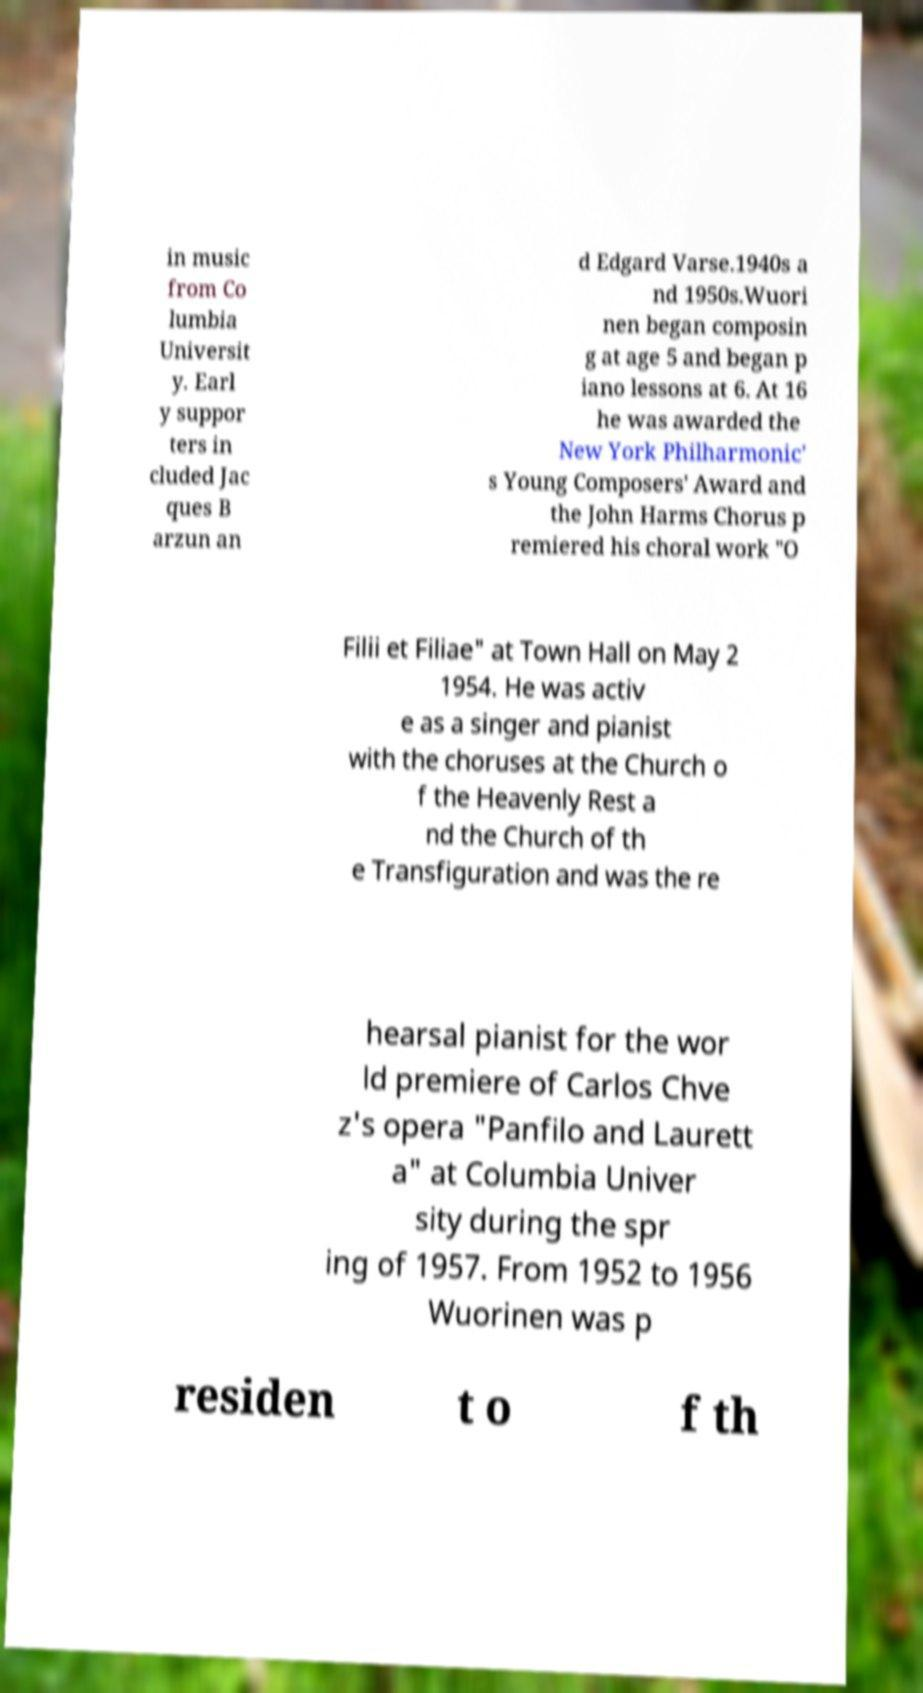There's text embedded in this image that I need extracted. Can you transcribe it verbatim? in music from Co lumbia Universit y. Earl y suppor ters in cluded Jac ques B arzun an d Edgard Varse.1940s a nd 1950s.Wuori nen began composin g at age 5 and began p iano lessons at 6. At 16 he was awarded the New York Philharmonic' s Young Composers' Award and the John Harms Chorus p remiered his choral work "O Filii et Filiae" at Town Hall on May 2 1954. He was activ e as a singer and pianist with the choruses at the Church o f the Heavenly Rest a nd the Church of th e Transfiguration and was the re hearsal pianist for the wor ld premiere of Carlos Chve z's opera "Panfilo and Laurett a" at Columbia Univer sity during the spr ing of 1957. From 1952 to 1956 Wuorinen was p residen t o f th 